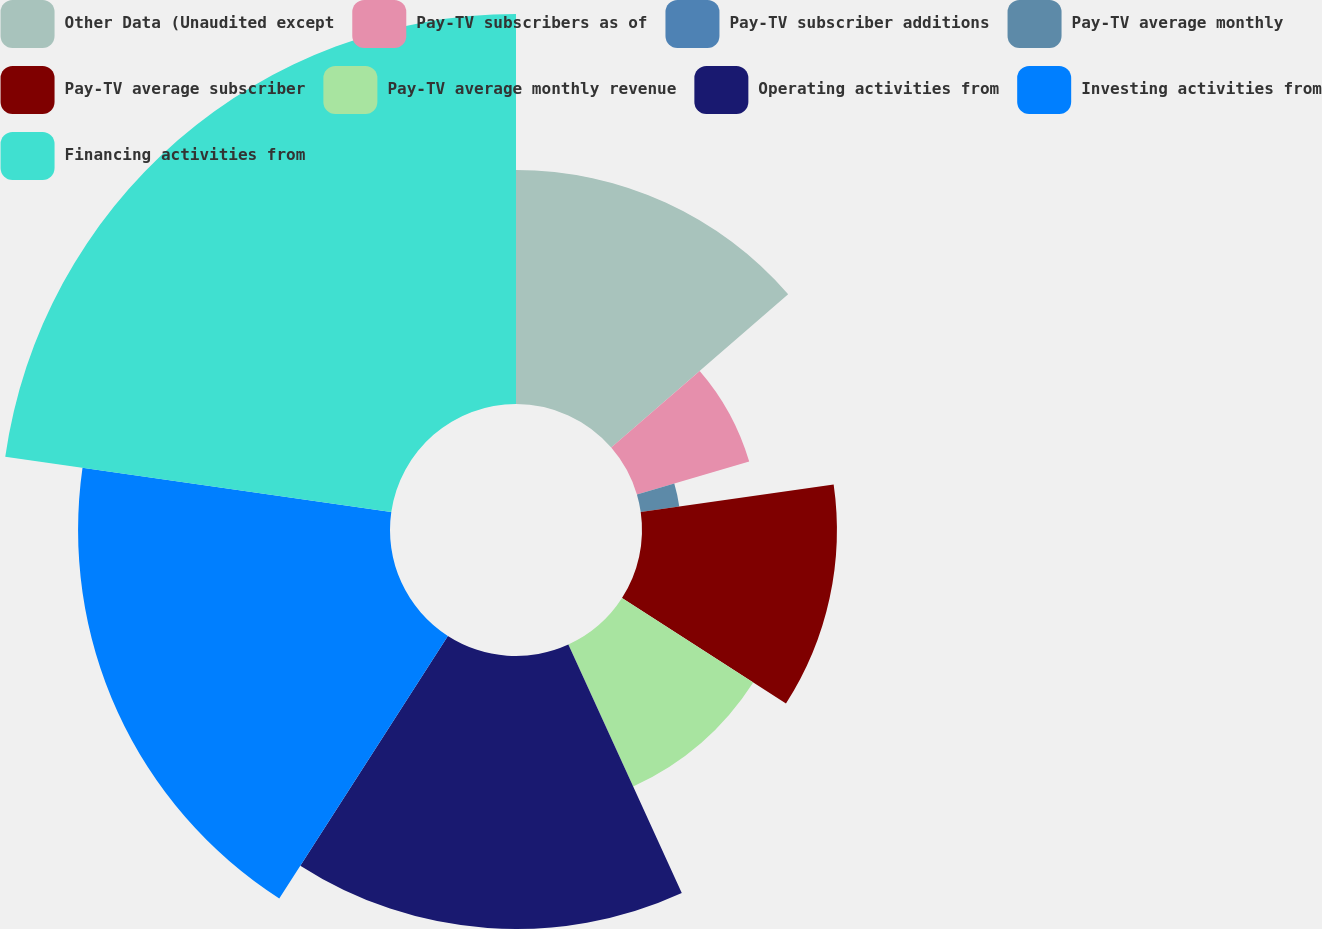<chart> <loc_0><loc_0><loc_500><loc_500><pie_chart><fcel>Other Data (Unaudited except<fcel>Pay-TV subscribers as of<fcel>Pay-TV subscriber additions<fcel>Pay-TV average monthly<fcel>Pay-TV average subscriber<fcel>Pay-TV average monthly revenue<fcel>Operating activities from<fcel>Investing activities from<fcel>Financing activities from<nl><fcel>13.64%<fcel>6.82%<fcel>0.0%<fcel>2.27%<fcel>11.36%<fcel>9.09%<fcel>15.91%<fcel>18.18%<fcel>22.73%<nl></chart> 